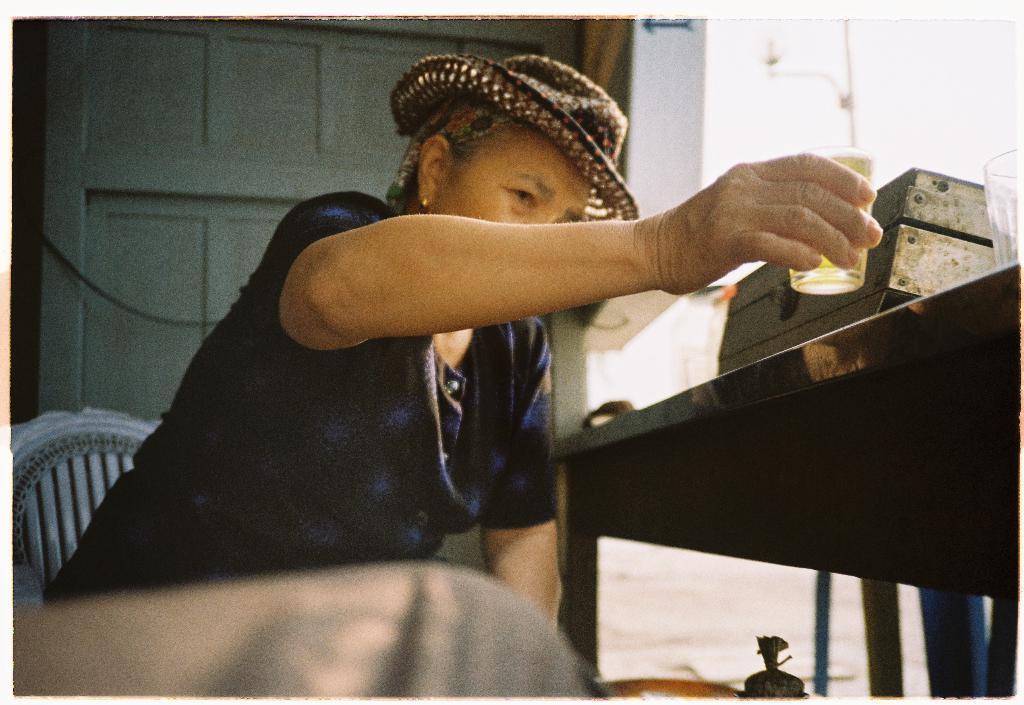Could you give a brief overview of what you see in this image? In this Image I see a person who is sitting on chair and the person is holding a glass and wearing a hat and I see a table over here on which there is another glass and a box. 